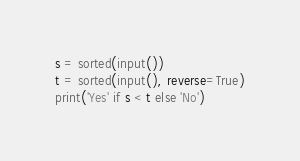<code> <loc_0><loc_0><loc_500><loc_500><_Python_>s = sorted(input())
t = sorted(input(), reverse=True)
print('Yes' if s < t else 'No')</code> 